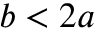<formula> <loc_0><loc_0><loc_500><loc_500>b < 2 a</formula> 